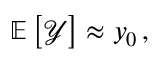Convert formula to latex. <formula><loc_0><loc_0><loc_500><loc_500>\mathbb { E } \left [ \mathcal { Y } \right ] \approx y _ { 0 } \, ,</formula> 